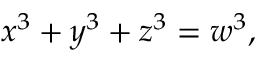Convert formula to latex. <formula><loc_0><loc_0><loc_500><loc_500>x ^ { 3 } + y ^ { 3 } + z ^ { 3 } = w ^ { 3 } ,</formula> 